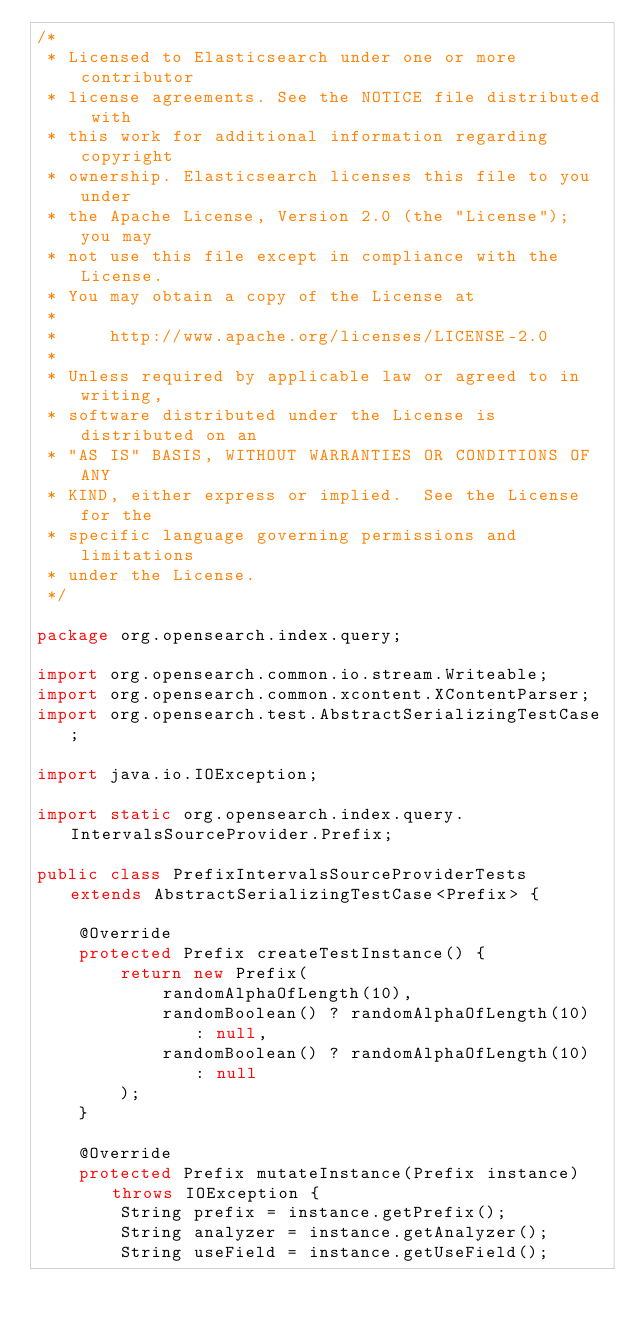<code> <loc_0><loc_0><loc_500><loc_500><_Java_>/*
 * Licensed to Elasticsearch under one or more contributor
 * license agreements. See the NOTICE file distributed with
 * this work for additional information regarding copyright
 * ownership. Elasticsearch licenses this file to you under
 * the Apache License, Version 2.0 (the "License"); you may
 * not use this file except in compliance with the License.
 * You may obtain a copy of the License at
 *
 *     http://www.apache.org/licenses/LICENSE-2.0
 *
 * Unless required by applicable law or agreed to in writing,
 * software distributed under the License is distributed on an
 * "AS IS" BASIS, WITHOUT WARRANTIES OR CONDITIONS OF ANY
 * KIND, either express or implied.  See the License for the
 * specific language governing permissions and limitations
 * under the License.
 */

package org.opensearch.index.query;

import org.opensearch.common.io.stream.Writeable;
import org.opensearch.common.xcontent.XContentParser;
import org.opensearch.test.AbstractSerializingTestCase;

import java.io.IOException;

import static org.opensearch.index.query.IntervalsSourceProvider.Prefix;

public class PrefixIntervalsSourceProviderTests extends AbstractSerializingTestCase<Prefix> {

    @Override
    protected Prefix createTestInstance() {
        return new Prefix(
            randomAlphaOfLength(10),
            randomBoolean() ? randomAlphaOfLength(10) : null,
            randomBoolean() ? randomAlphaOfLength(10) : null
        );
    }

    @Override
    protected Prefix mutateInstance(Prefix instance) throws IOException {
        String prefix = instance.getPrefix();
        String analyzer = instance.getAnalyzer();
        String useField = instance.getUseField();</code> 